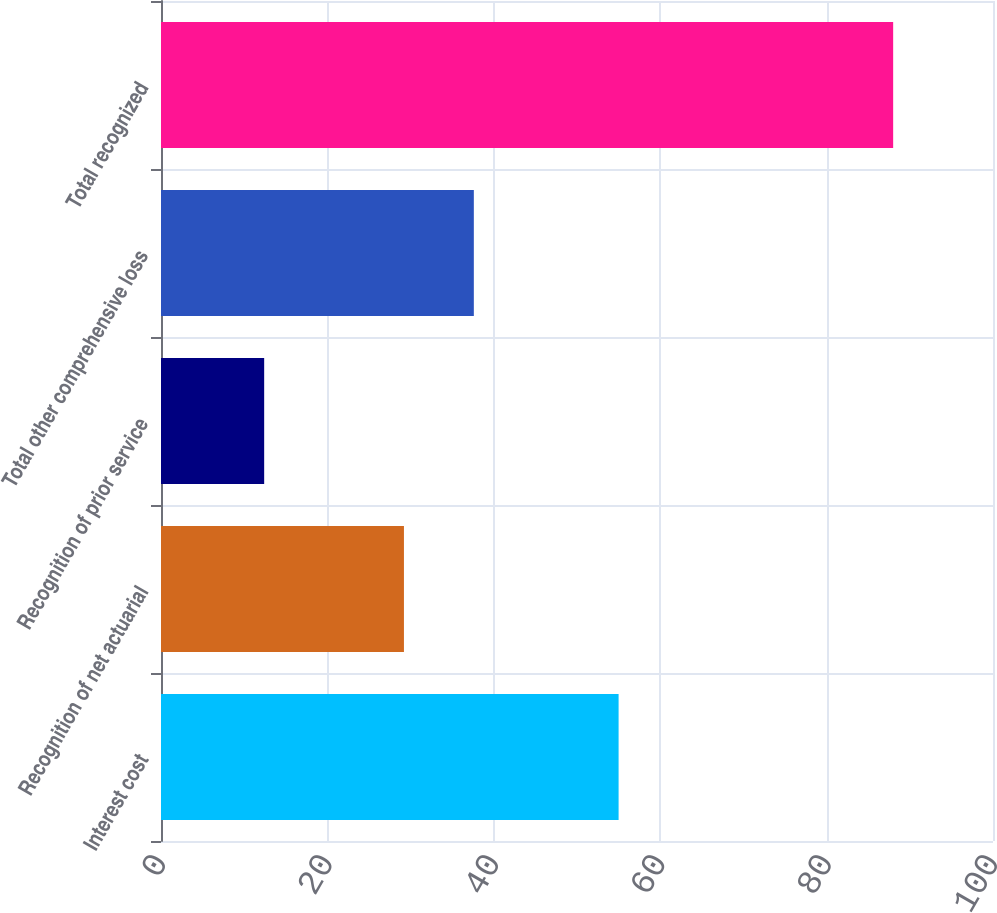Convert chart to OTSL. <chart><loc_0><loc_0><loc_500><loc_500><bar_chart><fcel>Interest cost<fcel>Recognition of net actuarial<fcel>Recognition of prior service<fcel>Total other comprehensive loss<fcel>Total recognized<nl><fcel>55<fcel>29.2<fcel>12.4<fcel>37.6<fcel>88<nl></chart> 